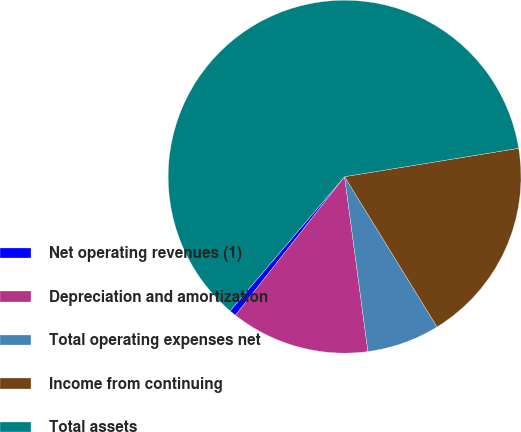Convert chart. <chart><loc_0><loc_0><loc_500><loc_500><pie_chart><fcel>Net operating revenues (1)<fcel>Depreciation and amortization<fcel>Total operating expenses net<fcel>Income from continuing<fcel>Total assets<nl><fcel>0.62%<fcel>12.73%<fcel>6.67%<fcel>18.79%<fcel>61.19%<nl></chart> 